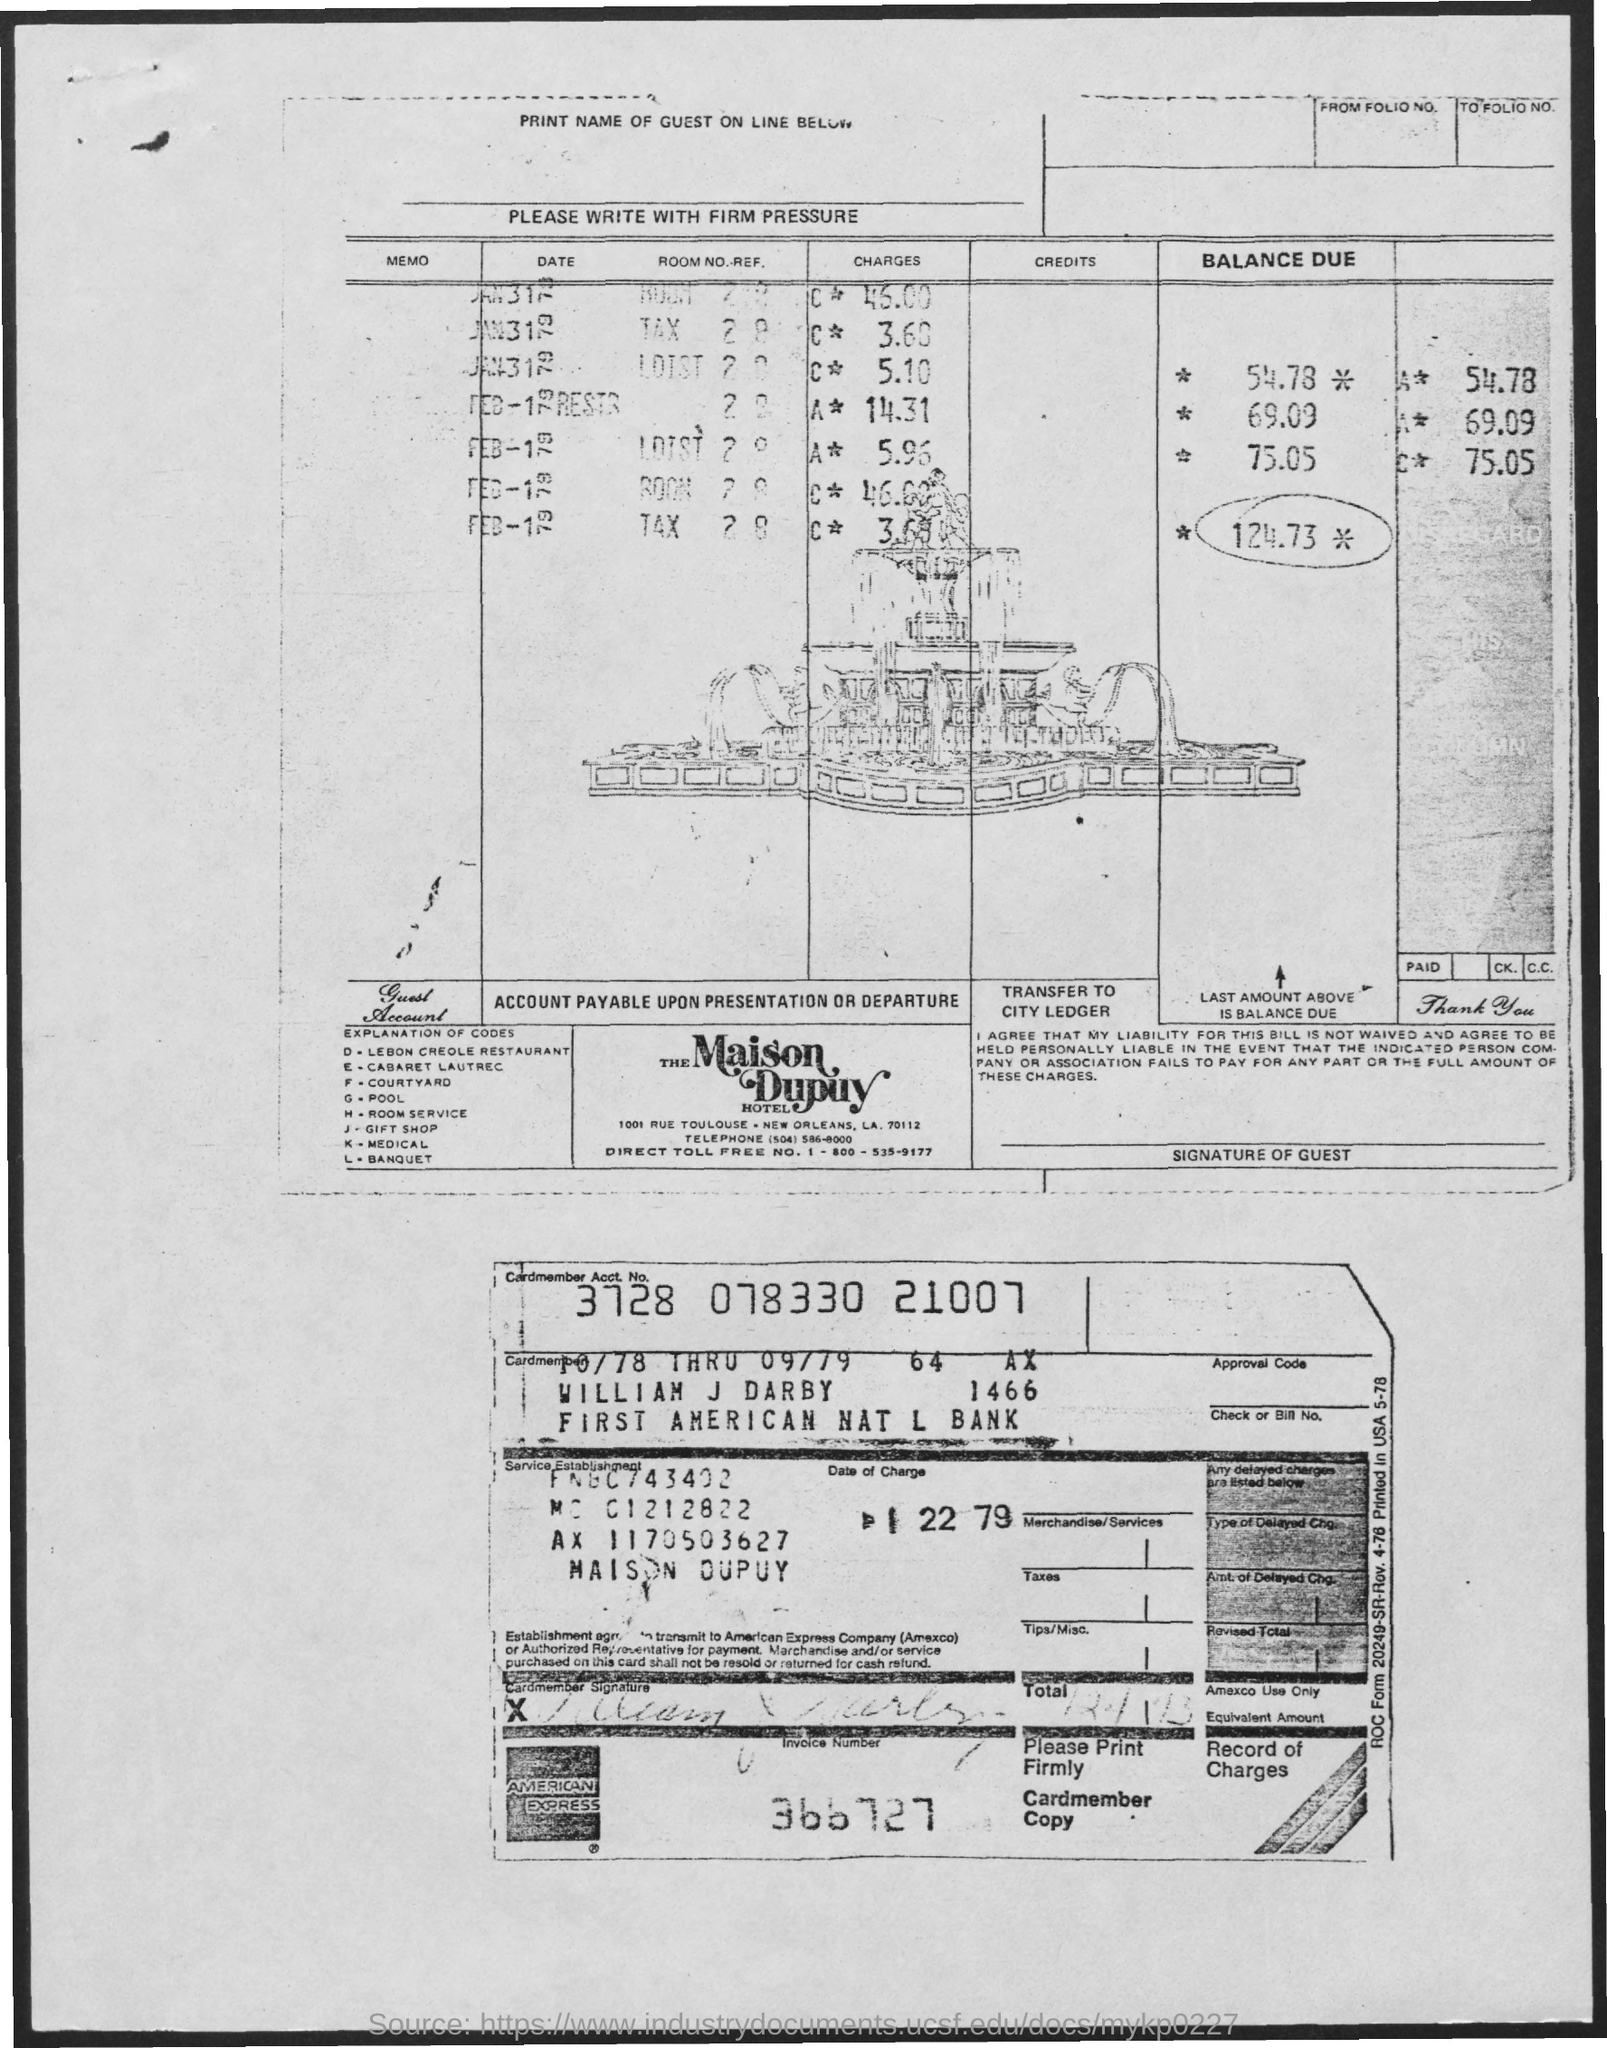What is the Cardmember Account Number?
Keep it short and to the point. 3728 078330 21007. What is the Invoice Number?
Offer a terse response. 366727. What is the explanation of code "G"?
Your response must be concise. Pool. What is the explanation of code "J"?
Your answer should be compact. Gift Shop. What is the explanation of code "H"?
Your answer should be very brief. Room service. 